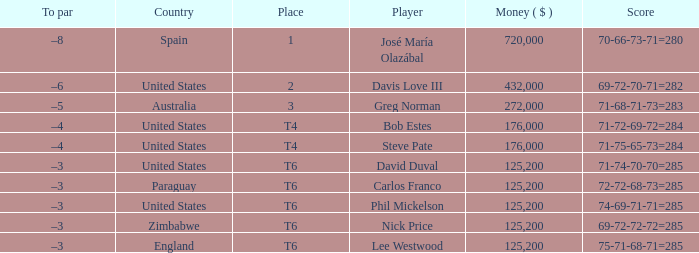Which average money has a Score of 69-72-72-72=285? 125200.0. 